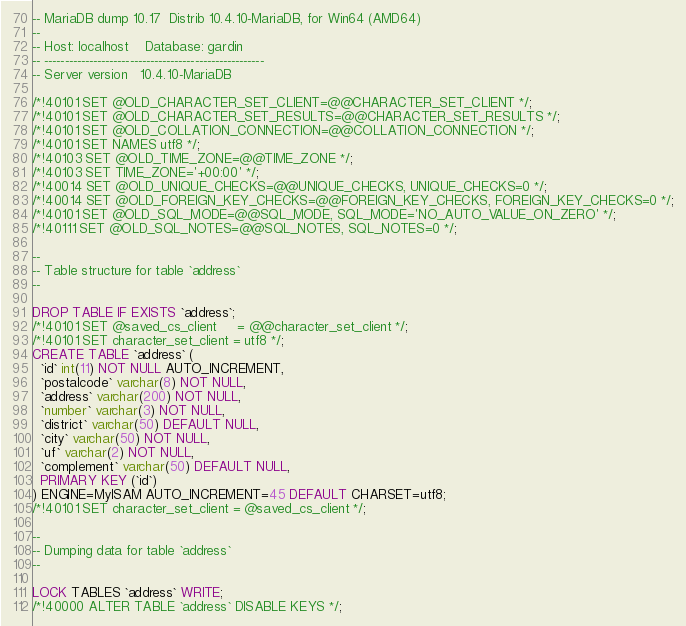<code> <loc_0><loc_0><loc_500><loc_500><_SQL_>-- MariaDB dump 10.17  Distrib 10.4.10-MariaDB, for Win64 (AMD64)
--
-- Host: localhost    Database: gardin
-- ------------------------------------------------------
-- Server version	10.4.10-MariaDB

/*!40101 SET @OLD_CHARACTER_SET_CLIENT=@@CHARACTER_SET_CLIENT */;
/*!40101 SET @OLD_CHARACTER_SET_RESULTS=@@CHARACTER_SET_RESULTS */;
/*!40101 SET @OLD_COLLATION_CONNECTION=@@COLLATION_CONNECTION */;
/*!40101 SET NAMES utf8 */;
/*!40103 SET @OLD_TIME_ZONE=@@TIME_ZONE */;
/*!40103 SET TIME_ZONE='+00:00' */;
/*!40014 SET @OLD_UNIQUE_CHECKS=@@UNIQUE_CHECKS, UNIQUE_CHECKS=0 */;
/*!40014 SET @OLD_FOREIGN_KEY_CHECKS=@@FOREIGN_KEY_CHECKS, FOREIGN_KEY_CHECKS=0 */;
/*!40101 SET @OLD_SQL_MODE=@@SQL_MODE, SQL_MODE='NO_AUTO_VALUE_ON_ZERO' */;
/*!40111 SET @OLD_SQL_NOTES=@@SQL_NOTES, SQL_NOTES=0 */;

--
-- Table structure for table `address`
--

DROP TABLE IF EXISTS `address`;
/*!40101 SET @saved_cs_client     = @@character_set_client */;
/*!40101 SET character_set_client = utf8 */;
CREATE TABLE `address` (
  `id` int(11) NOT NULL AUTO_INCREMENT,
  `postalcode` varchar(8) NOT NULL,
  `address` varchar(200) NOT NULL,
  `number` varchar(3) NOT NULL,
  `district` varchar(50) DEFAULT NULL,
  `city` varchar(50) NOT NULL,
  `uf` varchar(2) NOT NULL,
  `complement` varchar(50) DEFAULT NULL,
  PRIMARY KEY (`id`)
) ENGINE=MyISAM AUTO_INCREMENT=45 DEFAULT CHARSET=utf8;
/*!40101 SET character_set_client = @saved_cs_client */;

--
-- Dumping data for table `address`
--

LOCK TABLES `address` WRITE;
/*!40000 ALTER TABLE `address` DISABLE KEYS */;</code> 